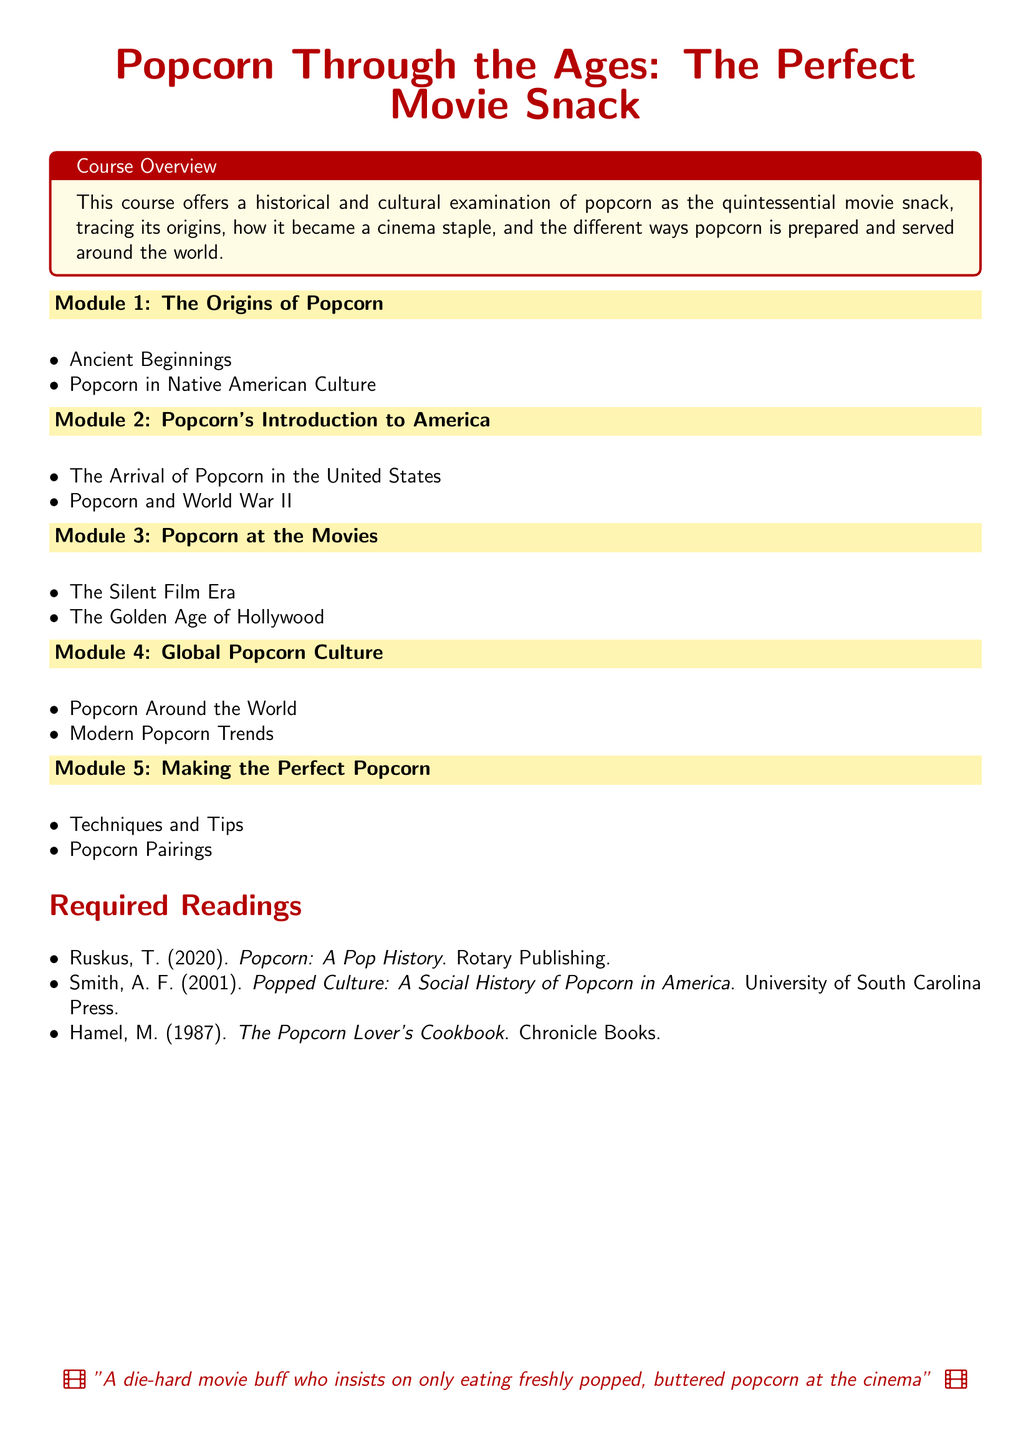What is the title of the syllabus? The title of the syllabus is stated in a prominent position and is "Popcorn Through the Ages: The Perfect Movie Snack."
Answer: Popcorn Through the Ages: The Perfect Movie Snack How many modules are included in the syllabus? The syllabus lists five distinct modules covering various aspects of popcorn.
Answer: 5 Who is the author of "Popped Culture: A Social History of Popcorn in America"? The syllabus provides the name of the author as A. F. Smith.
Answer: A. F. Smith What module covers the development of popcorn during the Silent Film Era? This topic is discussed in Module 3, which focuses on popcorn at the movies.
Answer: Module 3 What preparation aspect is addressed in Module 5? Module 5 includes a section on techniques and tips for making popcorn.
Answer: Techniques and Tips Which global aspect is highlighted in Module 4? Module 4 examines popcorn's cultural significance around the world.
Answer: Popcorn Around the World 